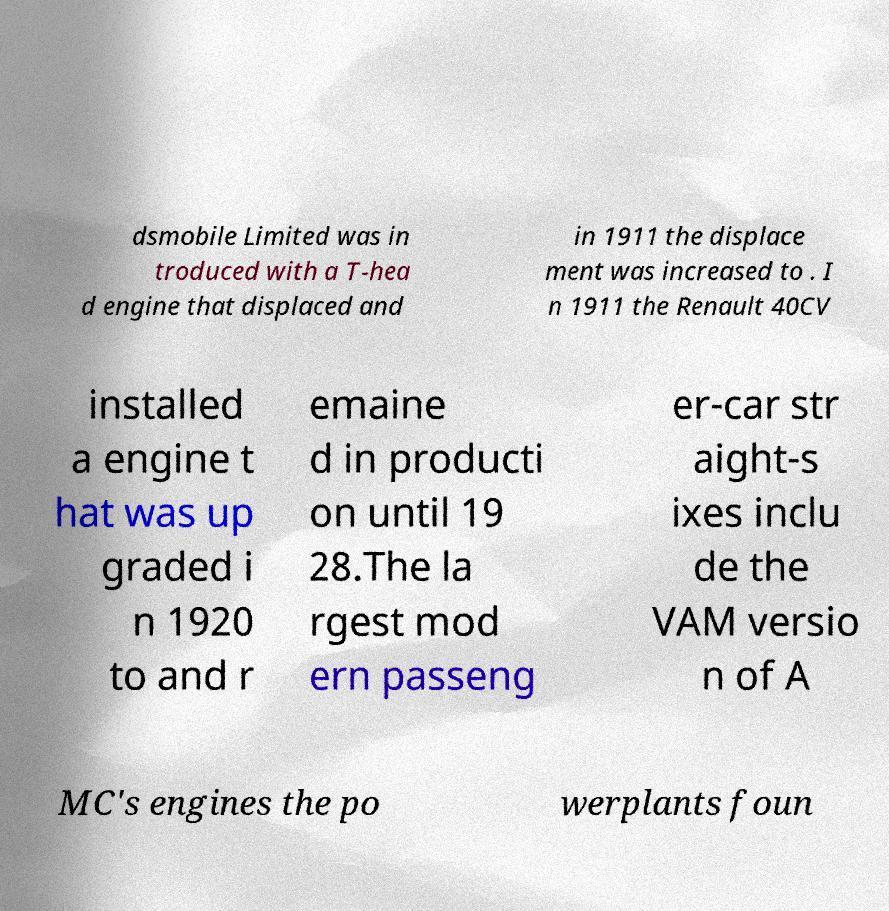There's text embedded in this image that I need extracted. Can you transcribe it verbatim? dsmobile Limited was in troduced with a T-hea d engine that displaced and in 1911 the displace ment was increased to . I n 1911 the Renault 40CV installed a engine t hat was up graded i n 1920 to and r emaine d in producti on until 19 28.The la rgest mod ern passeng er-car str aight-s ixes inclu de the VAM versio n of A MC's engines the po werplants foun 